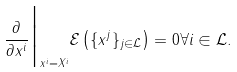<formula> <loc_0><loc_0><loc_500><loc_500>\frac { \partial } { \partial x ^ { i } } \Big | _ { x ^ { i } = X ^ { i } } \mathcal { E } \left ( \{ x ^ { j } \} _ { j \in \mathcal { L } } \right ) = 0 \forall i \in \mathcal { L } .</formula> 